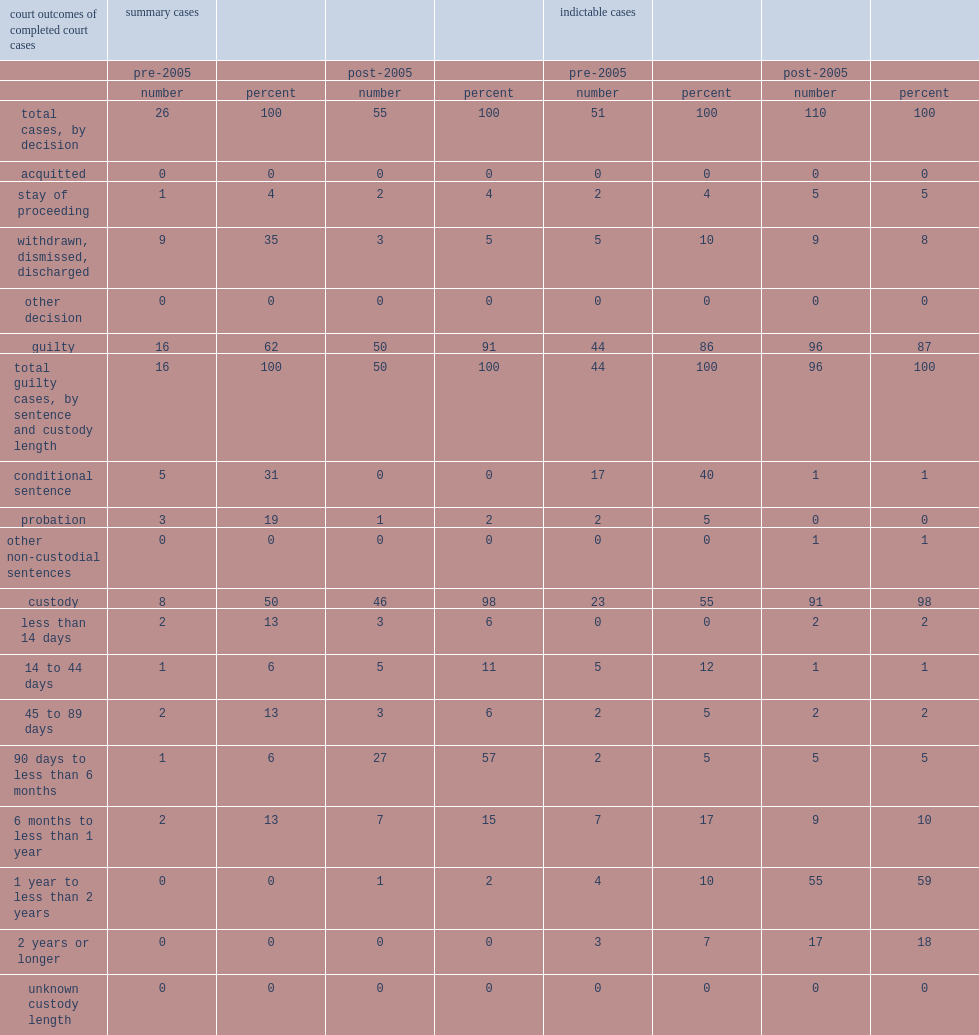What was the proportion of summary cases in conditional sentences before 2005? 31.0. What was the proportion of summary cases in probation before 2005? 19.0. What was the total proportion of summary cases that were probation and conditional sentences before 2005? 50. What was the proportion of indictable convictions resulted in conditional sentences before 2005? 40.0. What was the proportion of indictable convictions resulted in probation before 2005? 5.0. What was the total proportion of indictable convictions that resulted in conditional services and probation before 2005? 45. 